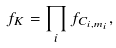Convert formula to latex. <formula><loc_0><loc_0><loc_500><loc_500>f _ { K } = \prod _ { i } f _ { C _ { i , m _ { i } } } ,</formula> 